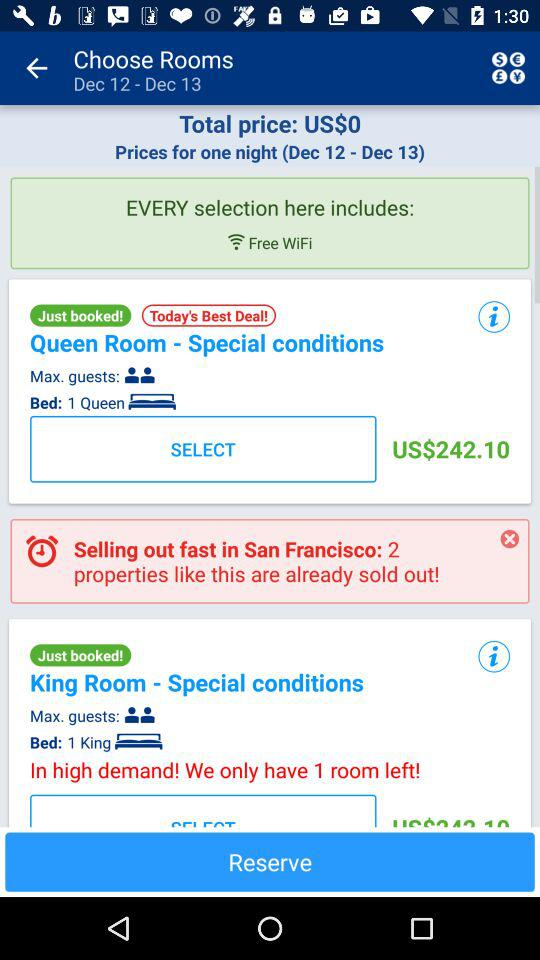For what dates are the rooms being chosen? The dates are December 12 and December 13. 